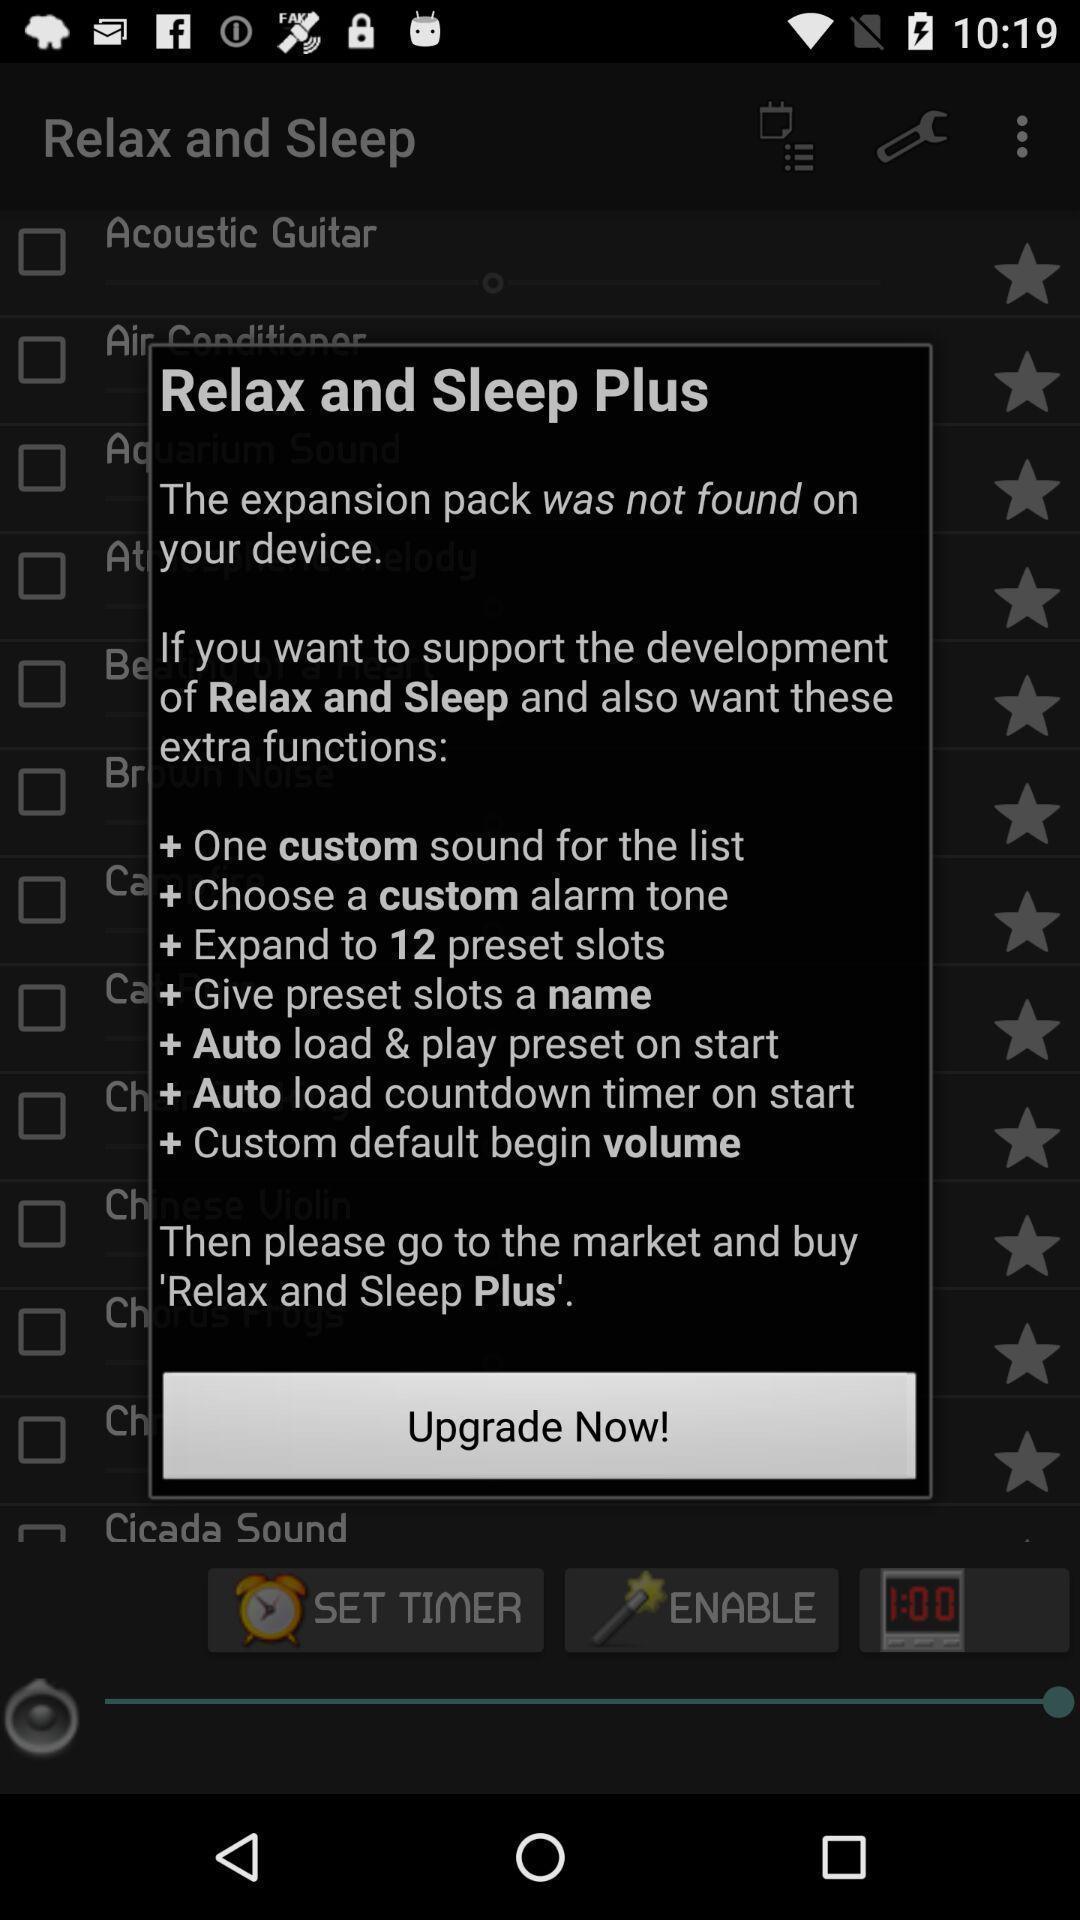Provide a textual representation of this image. Pop-up shows upgrade now option. 